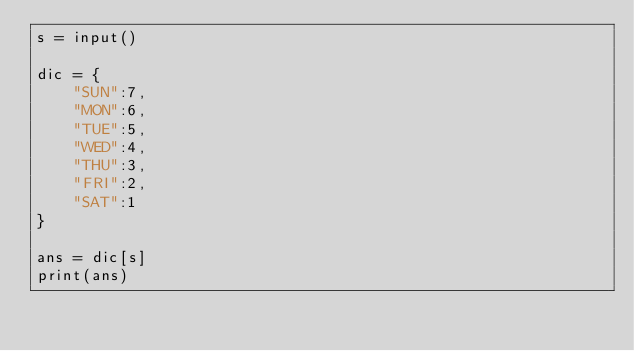<code> <loc_0><loc_0><loc_500><loc_500><_Python_>s = input()

dic = {
    "SUN":7,
    "MON":6,
    "TUE":5,
    "WED":4,
    "THU":3,
    "FRI":2,
    "SAT":1
}

ans = dic[s]
print(ans)</code> 